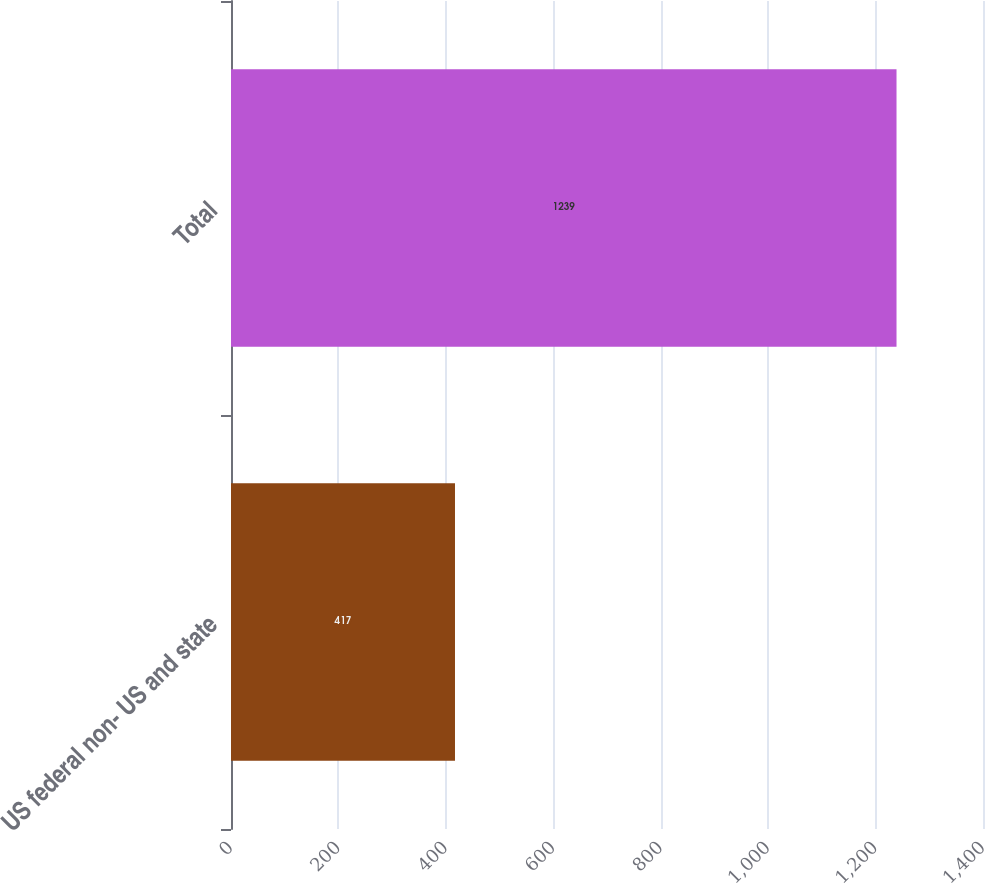<chart> <loc_0><loc_0><loc_500><loc_500><bar_chart><fcel>US federal non- US and state<fcel>Total<nl><fcel>417<fcel>1239<nl></chart> 